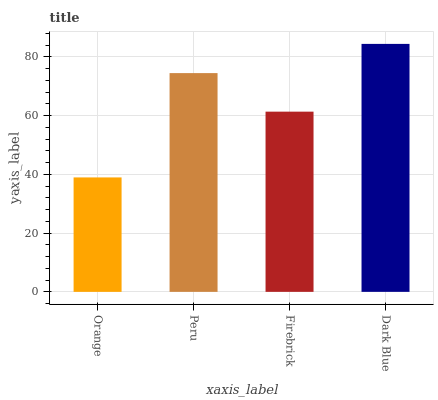Is Orange the minimum?
Answer yes or no. Yes. Is Dark Blue the maximum?
Answer yes or no. Yes. Is Peru the minimum?
Answer yes or no. No. Is Peru the maximum?
Answer yes or no. No. Is Peru greater than Orange?
Answer yes or no. Yes. Is Orange less than Peru?
Answer yes or no. Yes. Is Orange greater than Peru?
Answer yes or no. No. Is Peru less than Orange?
Answer yes or no. No. Is Peru the high median?
Answer yes or no. Yes. Is Firebrick the low median?
Answer yes or no. Yes. Is Dark Blue the high median?
Answer yes or no. No. Is Dark Blue the low median?
Answer yes or no. No. 